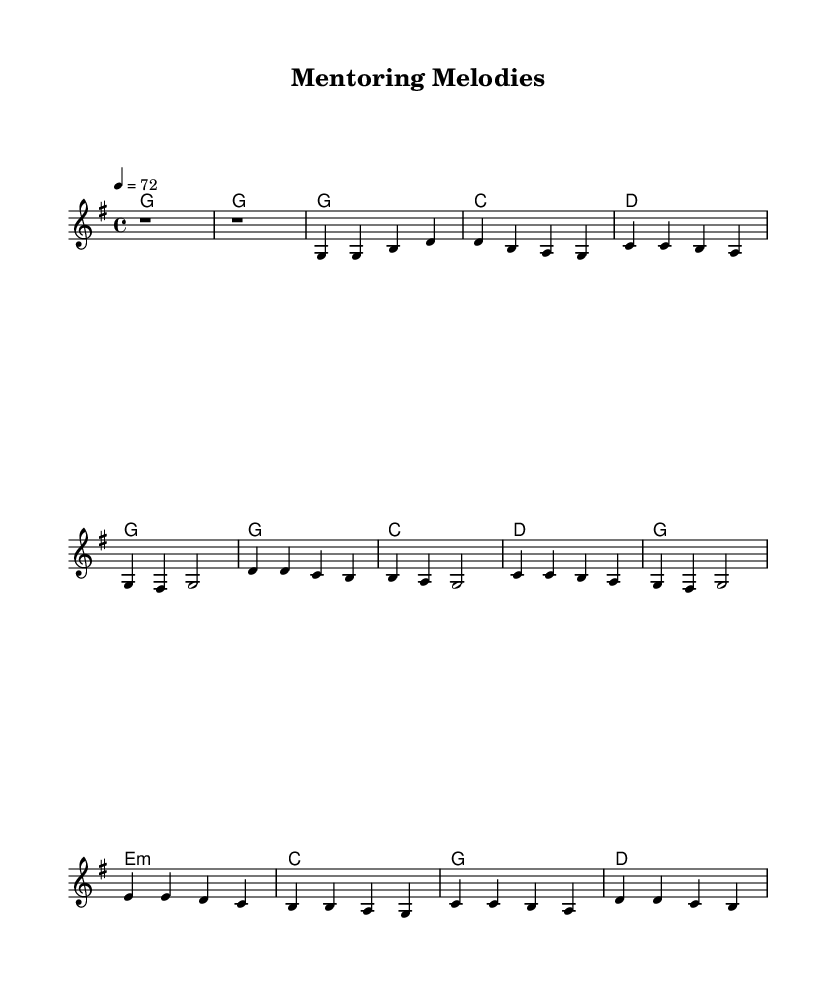What is the key signature of this music? The music is in G major, which has one sharp (F#). This can be determined by observing the key signature at the beginning of the staff.
Answer: G major What is the time signature of this music? The time signature is 4/4, indicated at the beginning of the score. This means there are four beats in each measure, and the quarter note gets one beat.
Answer: 4/4 What is the tempo marking of this music? The tempo marking is 72 beats per minute, found at the start of the global settings. This specifies how fast the music should be played.
Answer: 72 What is the primary theme of the lyrics? The lyrics focus on teamwork and collaboration in a workplace setting, as suggested by the lines about guiding rookies and learning together. This reflects the classic country ballad's storytelling nature.
Answer: Teamwork How many measures are there in the chorus? The chorus consists of four measures, which can be counted from the musical notation provided in the score. Each measure contains the rhythmic and melodic structure for that part.
Answer: 4 What type of musical structure is used in the song? The song follows a verse-chorus structure, typical of many country ballads, which allows for storytelling through distinct sections. This can be identified by the presence of a verse followed by a repeated chorus.
Answer: Verse-Chorus What is the harmonic progression used in the first verse? The harmonic progression in the first verse follows a G-C-D-G pattern, which is a common progression in country music, giving it a familiar and comforting sound. This is seen by examining the chord changes under the melody.
Answer: G-C-D-G 